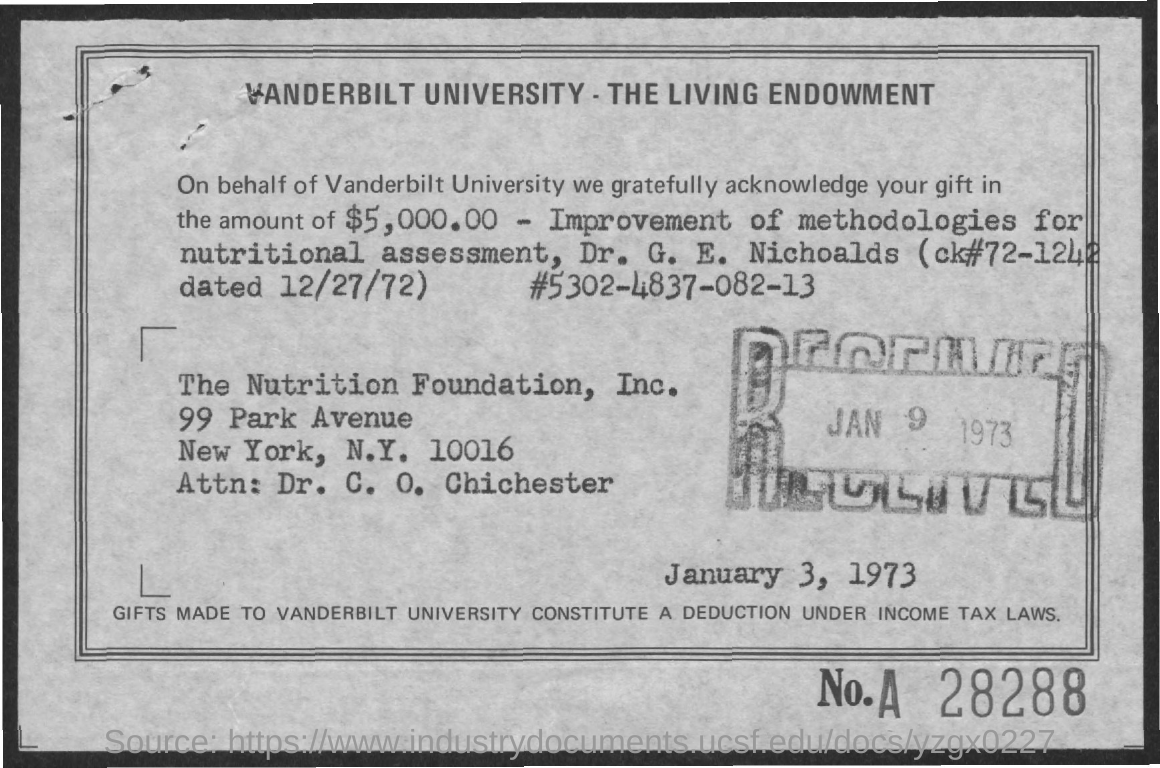What is the amount of gift mentioned in the living endowment ?
Provide a short and direct response. $5,000.00. On which date it was received ?
Your response must be concise. JAN 9, 1973. What is the name of the university ?
Your answer should be very brief. Vanderbilt University. 